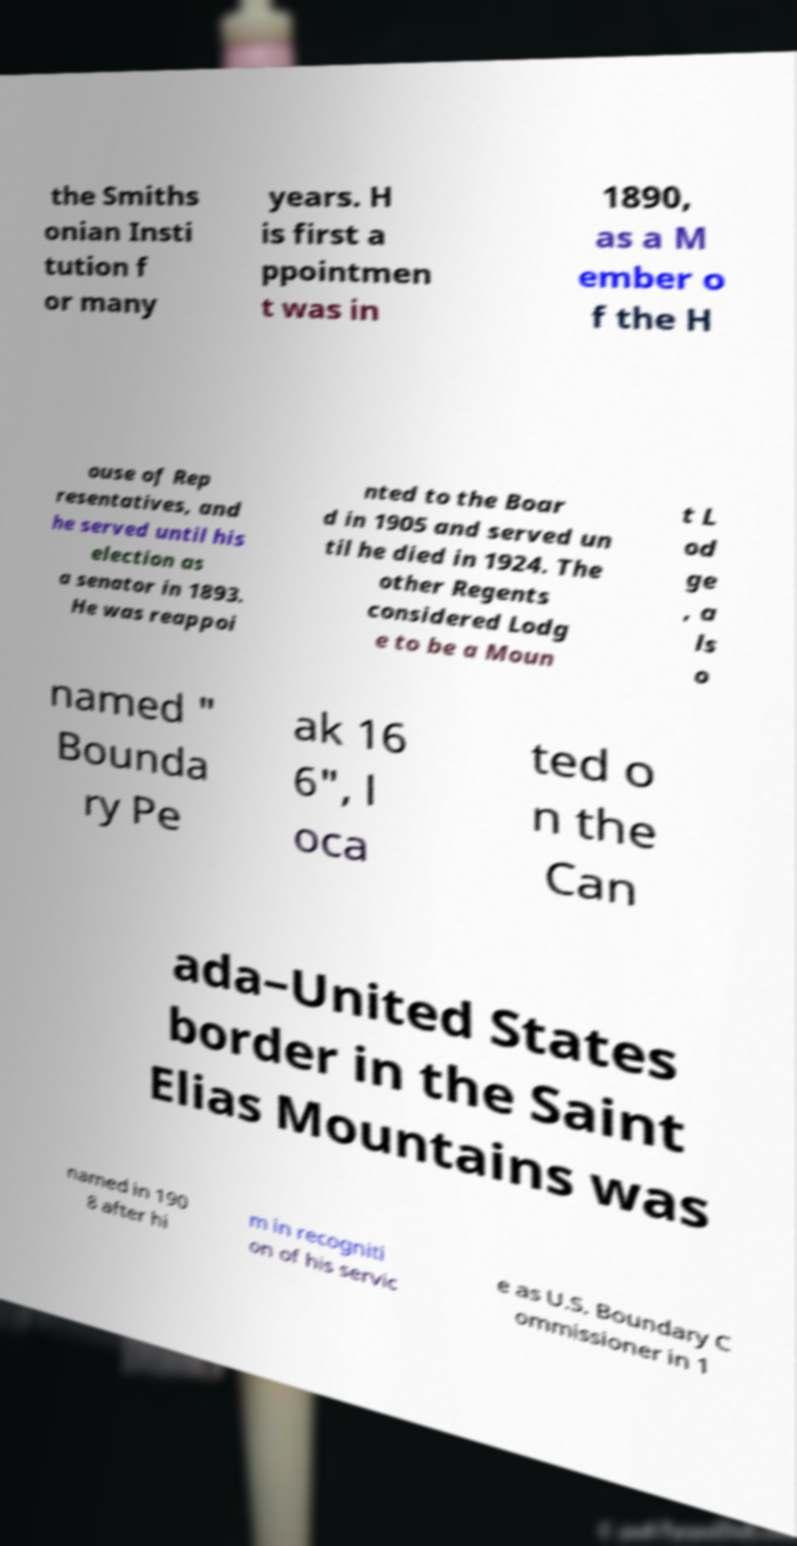For documentation purposes, I need the text within this image transcribed. Could you provide that? the Smiths onian Insti tution f or many years. H is first a ppointmen t was in 1890, as a M ember o f the H ouse of Rep resentatives, and he served until his election as a senator in 1893. He was reappoi nted to the Boar d in 1905 and served un til he died in 1924. The other Regents considered Lodg e to be a Moun t L od ge , a ls o named " Bounda ry Pe ak 16 6", l oca ted o n the Can ada–United States border in the Saint Elias Mountains was named in 190 8 after hi m in recogniti on of his servic e as U.S. Boundary C ommissioner in 1 